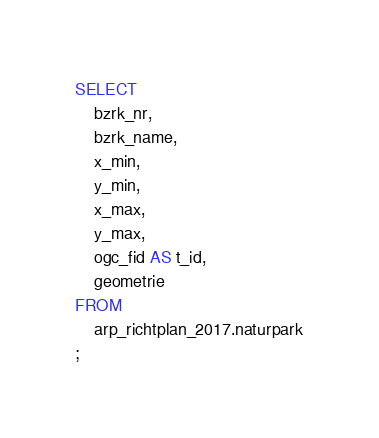Convert code to text. <code><loc_0><loc_0><loc_500><loc_500><_SQL_>SELECT
    bzrk_nr,
    bzrk_name,
    x_min,
    y_min,
    x_max,
    y_max,
    ogc_fid AS t_id,
    geometrie
FROM
    arp_richtplan_2017.naturpark
;</code> 